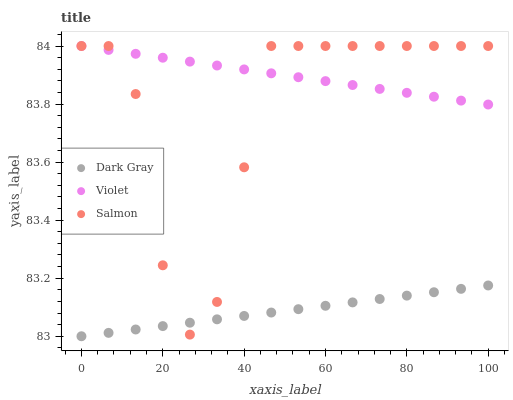Does Dark Gray have the minimum area under the curve?
Answer yes or no. Yes. Does Violet have the maximum area under the curve?
Answer yes or no. Yes. Does Salmon have the minimum area under the curve?
Answer yes or no. No. Does Salmon have the maximum area under the curve?
Answer yes or no. No. Is Dark Gray the smoothest?
Answer yes or no. Yes. Is Salmon the roughest?
Answer yes or no. Yes. Is Violet the smoothest?
Answer yes or no. No. Is Violet the roughest?
Answer yes or no. No. Does Dark Gray have the lowest value?
Answer yes or no. Yes. Does Salmon have the lowest value?
Answer yes or no. No. Does Violet have the highest value?
Answer yes or no. Yes. Is Dark Gray less than Violet?
Answer yes or no. Yes. Is Violet greater than Dark Gray?
Answer yes or no. Yes. Does Violet intersect Salmon?
Answer yes or no. Yes. Is Violet less than Salmon?
Answer yes or no. No. Is Violet greater than Salmon?
Answer yes or no. No. Does Dark Gray intersect Violet?
Answer yes or no. No. 